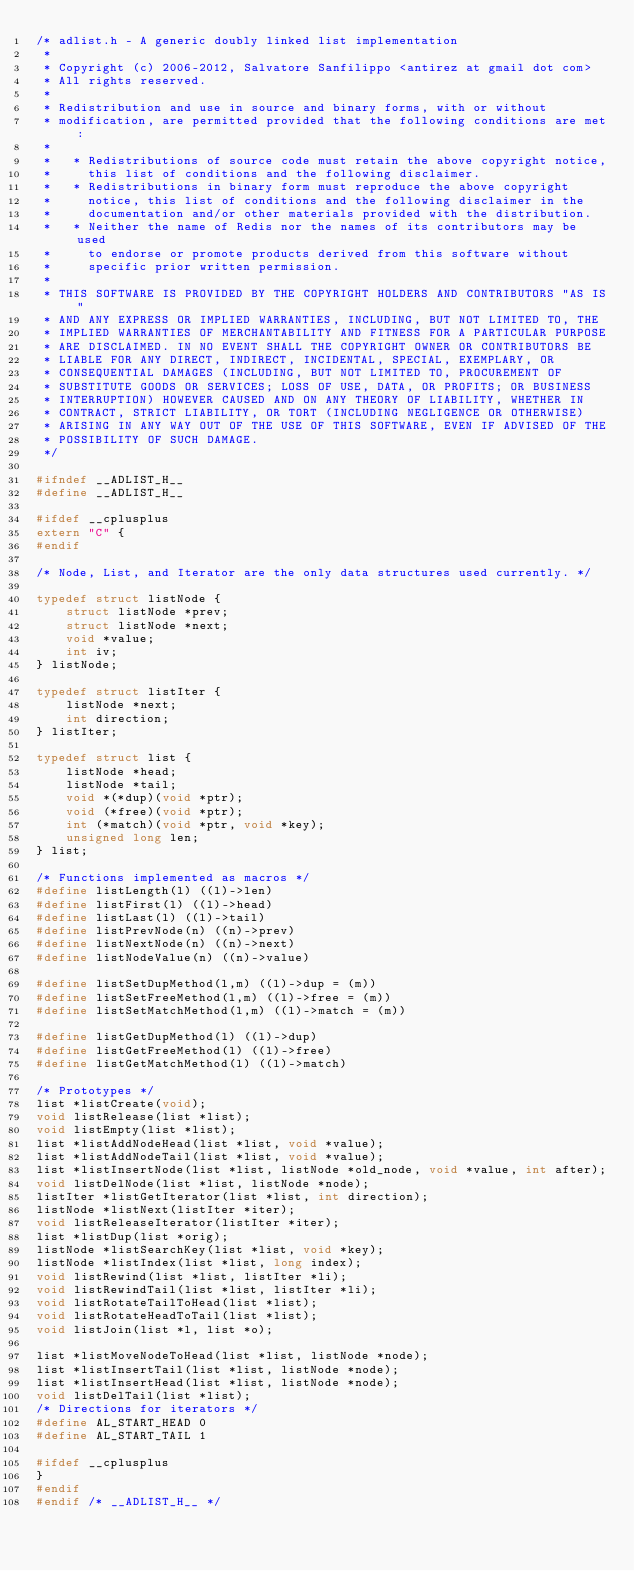<code> <loc_0><loc_0><loc_500><loc_500><_C_>/* adlist.h - A generic doubly linked list implementation
 *
 * Copyright (c) 2006-2012, Salvatore Sanfilippo <antirez at gmail dot com>
 * All rights reserved.
 *
 * Redistribution and use in source and binary forms, with or without
 * modification, are permitted provided that the following conditions are met:
 *
 *   * Redistributions of source code must retain the above copyright notice,
 *     this list of conditions and the following disclaimer.
 *   * Redistributions in binary form must reproduce the above copyright
 *     notice, this list of conditions and the following disclaimer in the
 *     documentation and/or other materials provided with the distribution.
 *   * Neither the name of Redis nor the names of its contributors may be used
 *     to endorse or promote products derived from this software without
 *     specific prior written permission.
 *
 * THIS SOFTWARE IS PROVIDED BY THE COPYRIGHT HOLDERS AND CONTRIBUTORS "AS IS"
 * AND ANY EXPRESS OR IMPLIED WARRANTIES, INCLUDING, BUT NOT LIMITED TO, THE
 * IMPLIED WARRANTIES OF MERCHANTABILITY AND FITNESS FOR A PARTICULAR PURPOSE
 * ARE DISCLAIMED. IN NO EVENT SHALL THE COPYRIGHT OWNER OR CONTRIBUTORS BE
 * LIABLE FOR ANY DIRECT, INDIRECT, INCIDENTAL, SPECIAL, EXEMPLARY, OR
 * CONSEQUENTIAL DAMAGES (INCLUDING, BUT NOT LIMITED TO, PROCUREMENT OF
 * SUBSTITUTE GOODS OR SERVICES; LOSS OF USE, DATA, OR PROFITS; OR BUSINESS
 * INTERRUPTION) HOWEVER CAUSED AND ON ANY THEORY OF LIABILITY, WHETHER IN
 * CONTRACT, STRICT LIABILITY, OR TORT (INCLUDING NEGLIGENCE OR OTHERWISE)
 * ARISING IN ANY WAY OUT OF THE USE OF THIS SOFTWARE, EVEN IF ADVISED OF THE
 * POSSIBILITY OF SUCH DAMAGE.
 */

#ifndef __ADLIST_H__
#define __ADLIST_H__

#ifdef __cplusplus
extern "C" {
#endif

/* Node, List, and Iterator are the only data structures used currently. */

typedef struct listNode {
    struct listNode *prev;
    struct listNode *next;
    void *value;
    int iv;
} listNode;

typedef struct listIter {
    listNode *next;
    int direction;
} listIter;

typedef struct list {
    listNode *head;
    listNode *tail;
    void *(*dup)(void *ptr);
    void (*free)(void *ptr);
    int (*match)(void *ptr, void *key);
    unsigned long len;
} list;

/* Functions implemented as macros */
#define listLength(l) ((l)->len)
#define listFirst(l) ((l)->head)
#define listLast(l) ((l)->tail)
#define listPrevNode(n) ((n)->prev)
#define listNextNode(n) ((n)->next)
#define listNodeValue(n) ((n)->value)

#define listSetDupMethod(l,m) ((l)->dup = (m))
#define listSetFreeMethod(l,m) ((l)->free = (m))
#define listSetMatchMethod(l,m) ((l)->match = (m))

#define listGetDupMethod(l) ((l)->dup)
#define listGetFreeMethod(l) ((l)->free)
#define listGetMatchMethod(l) ((l)->match)

/* Prototypes */
list *listCreate(void);
void listRelease(list *list);
void listEmpty(list *list);
list *listAddNodeHead(list *list, void *value);
list *listAddNodeTail(list *list, void *value);
list *listInsertNode(list *list, listNode *old_node, void *value, int after);
void listDelNode(list *list, listNode *node);
listIter *listGetIterator(list *list, int direction);
listNode *listNext(listIter *iter);
void listReleaseIterator(listIter *iter);
list *listDup(list *orig);
listNode *listSearchKey(list *list, void *key);
listNode *listIndex(list *list, long index);
void listRewind(list *list, listIter *li);
void listRewindTail(list *list, listIter *li);
void listRotateTailToHead(list *list);
void listRotateHeadToTail(list *list);
void listJoin(list *l, list *o);

list *listMoveNodeToHead(list *list, listNode *node);
list *listInsertTail(list *list, listNode *node);
list *listInsertHead(list *list, listNode *node);
void listDelTail(list *list);
/* Directions for iterators */
#define AL_START_HEAD 0
#define AL_START_TAIL 1

#ifdef __cplusplus
}
#endif
#endif /* __ADLIST_H__ */
</code> 